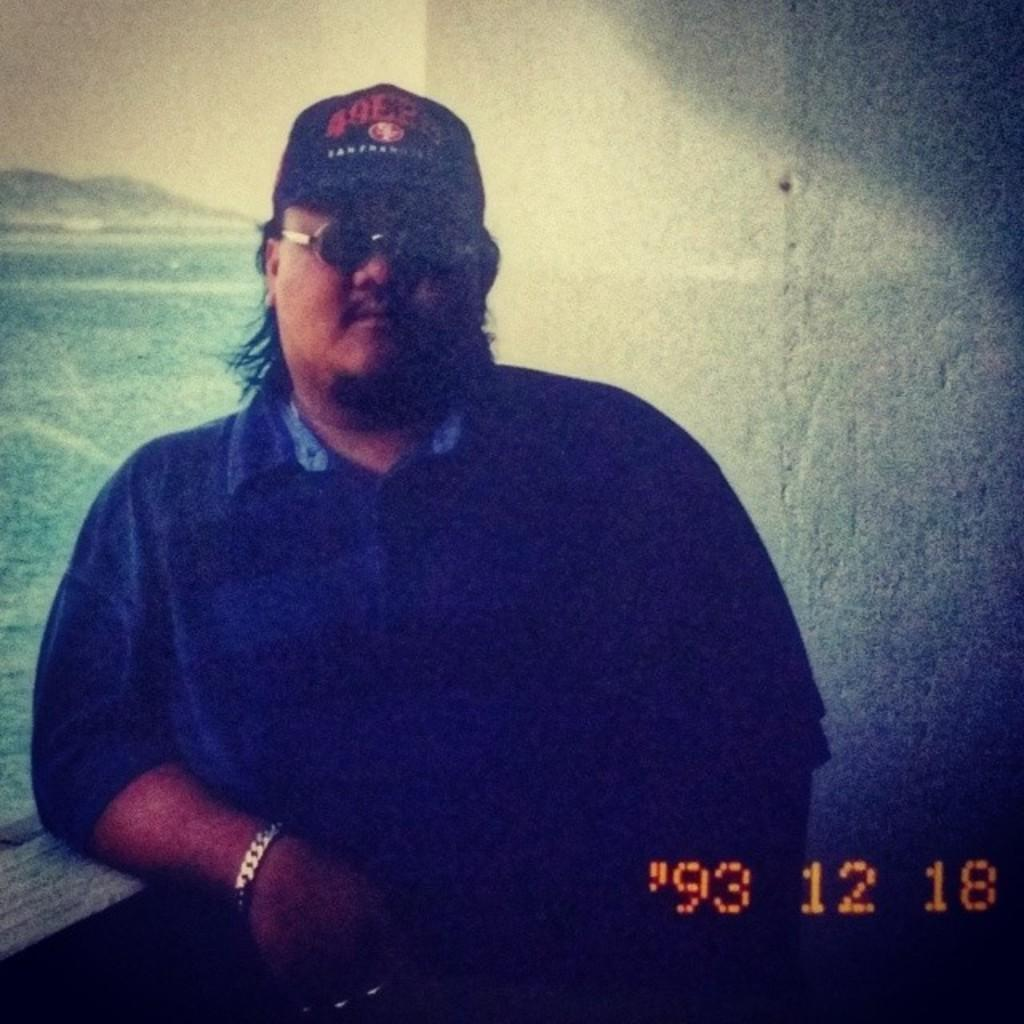Who or what is present in the image? There is a person in the image. What can be seen behind the person? There is a wall visible in the image. What is the person standing near or in? There is water in the image. What is visible above the person and the wall? The sky is visible at the top of the image. How many oranges are on the person's head in the image? There are no oranges present in the image. What type of snake can be seen slithering near the person in the image? There is no snake present in the image. 